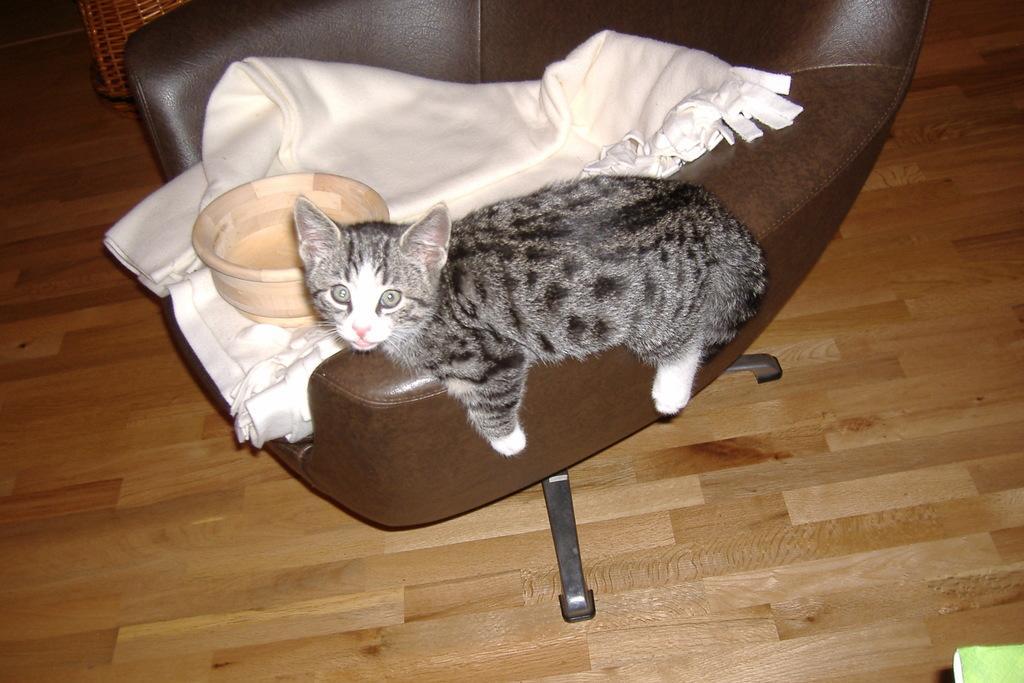Please provide a concise description of this image. In this image we can see a cat, bowl and a blanket on a chair which is placed on the wooden floor. At the top left we can see a basket. 